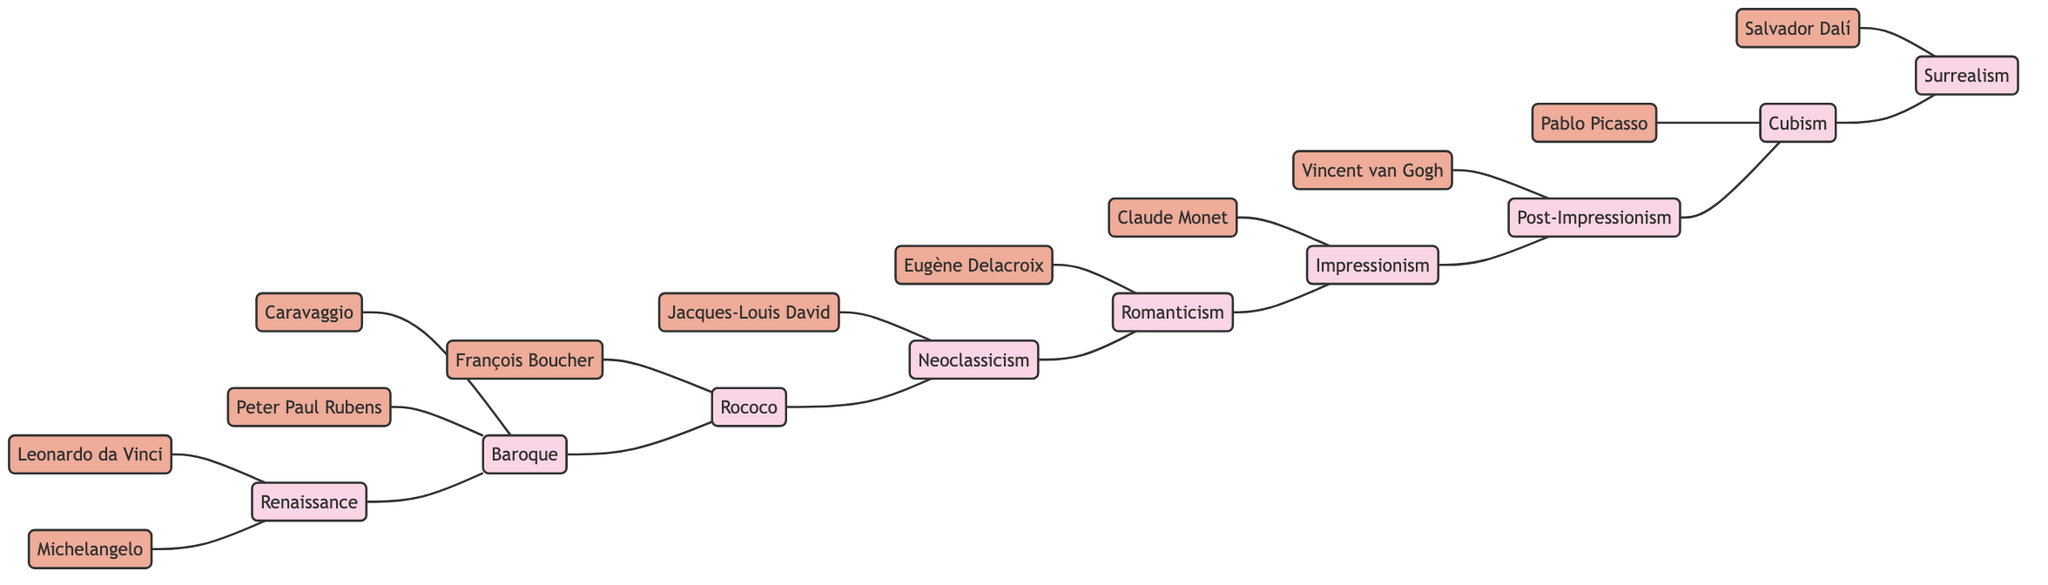What is the total number of art movements depicted in the diagram? The diagram lists nine different art movements as nodes: Renaissance, Baroque, Rococo, Neoclassicism, Romanticism, Impressionism, Post-Impressionism, Cubism, and Surrealism. Counting these gives a total of 9 movements.
Answer: 9 Which artist is associated with the Romanticism movement? According to the diagram, Eugène Delacroix is the artist connected to the Romanticism node, indicating that he is one of its main representatives.
Answer: Eugène Delacroix Which two movements are directly related to Impressionism? The diagram shows that Impressionism is connected to both Romanticism (as a predecessor) and Post-Impressionism (as a successor), indicating that these movements are directly related to it.
Answer: Romanticism, Post-Impressionism How many artists are linked to the Baroque movement? The diagram shows two artists connected to the Baroque movement: Caravaggio and Peter Paul Rubens. This indicates that there are two artists specifically identified with this movement.
Answer: 2 Which art movement comes after Neoclassicism in the sequence? The edges in the diagram illustrate that Neoclassicism is followed by Romanticism, indicating the chronological relationship in the evolution of art movements.
Answer: Romanticism Which artist is the only one depicted in connection with Cubism? The diagram indicates that only Pablo Picasso is linked to the Cubism movement, highlighting his distinct association as a prominent figure in this specific art movement.
Answer: Pablo Picasso What is the relationship between Surrealism and Cubism? The diagram shows that Surrealism is directly connected to Cubism through an edge, indicating a sequential relationship where Cubism leads into Surrealism in the evolution of art movements.
Answer: Directly connected Name one artist connected to the Rococo movement. François Boucher is identified in the diagram as the artist who is associated with the Rococo movement, marking him as a representative of that particular art style.
Answer: François Boucher How many edges are present in the diagram? The diagram's edges represent relationships and connections between the various nodes. By counting, there are 16 edges in total, illustrating the diverse interconnections among the movements and artists.
Answer: 16 